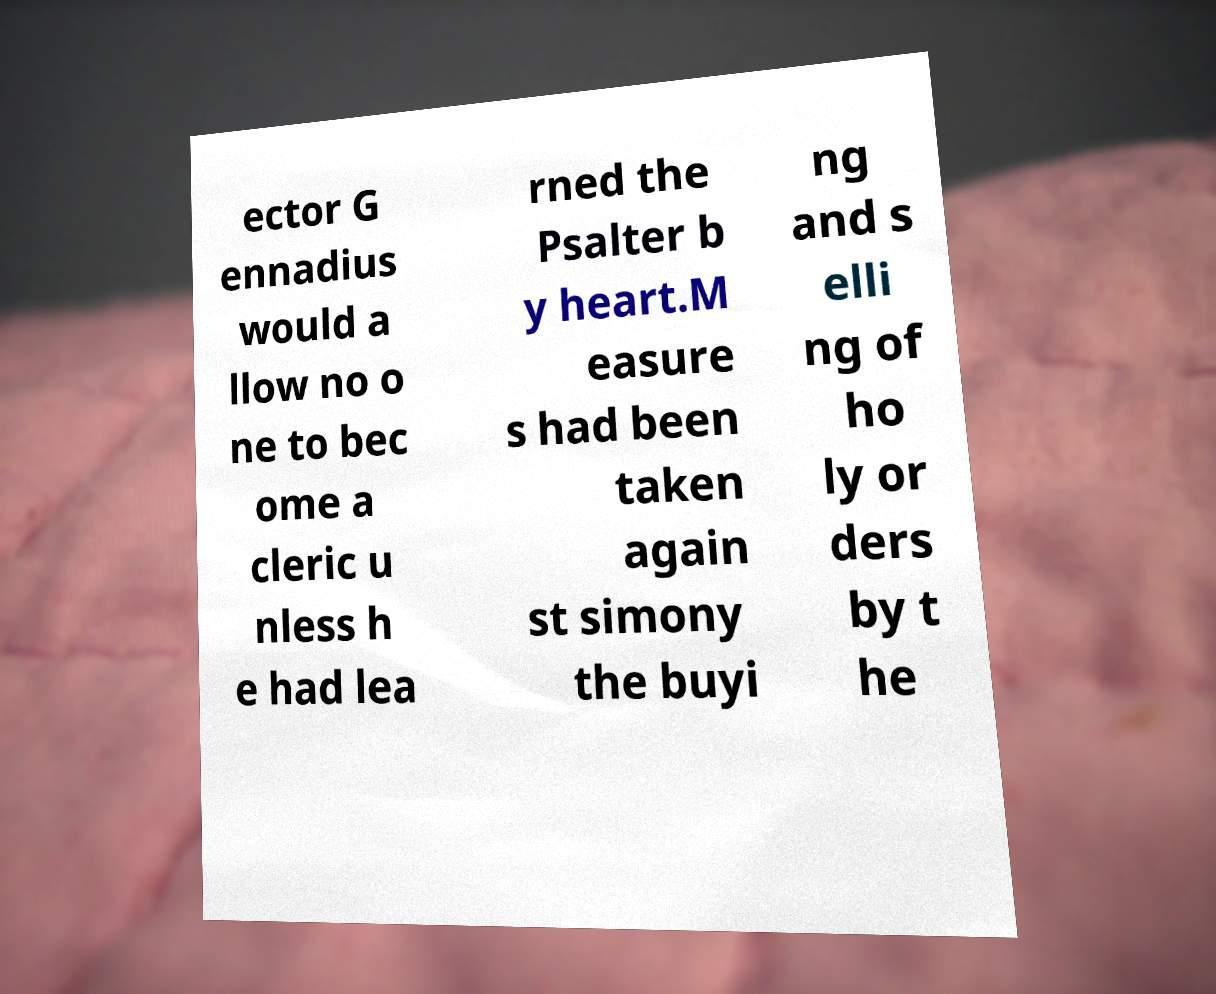Please identify and transcribe the text found in this image. ector G ennadius would a llow no o ne to bec ome a cleric u nless h e had lea rned the Psalter b y heart.M easure s had been taken again st simony the buyi ng and s elli ng of ho ly or ders by t he 